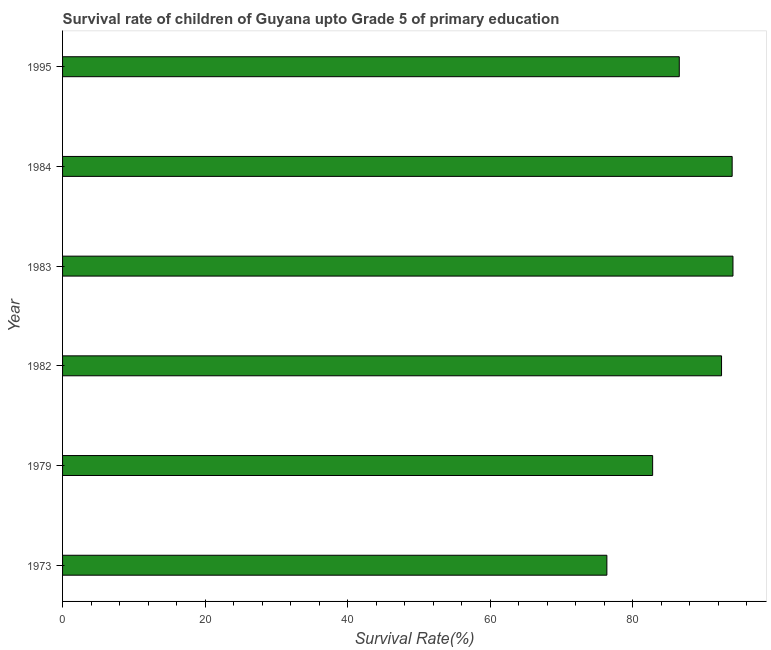Does the graph contain any zero values?
Your answer should be very brief. No. What is the title of the graph?
Offer a very short reply. Survival rate of children of Guyana upto Grade 5 of primary education. What is the label or title of the X-axis?
Ensure brevity in your answer.  Survival Rate(%). What is the label or title of the Y-axis?
Make the answer very short. Year. What is the survival rate in 1982?
Offer a terse response. 92.47. Across all years, what is the maximum survival rate?
Provide a succinct answer. 94.07. Across all years, what is the minimum survival rate?
Provide a short and direct response. 76.38. In which year was the survival rate maximum?
Keep it short and to the point. 1983. In which year was the survival rate minimum?
Your answer should be very brief. 1973. What is the sum of the survival rate?
Keep it short and to the point. 526.2. What is the difference between the survival rate in 1973 and 1979?
Ensure brevity in your answer.  -6.42. What is the average survival rate per year?
Your response must be concise. 87.7. What is the median survival rate?
Make the answer very short. 89.5. Do a majority of the years between 1984 and 1979 (inclusive) have survival rate greater than 84 %?
Keep it short and to the point. Yes. What is the ratio of the survival rate in 1982 to that in 1995?
Make the answer very short. 1.07. Is the survival rate in 1973 less than that in 1984?
Keep it short and to the point. Yes. Is the difference between the survival rate in 1973 and 1995 greater than the difference between any two years?
Provide a short and direct response. No. What is the difference between the highest and the second highest survival rate?
Your answer should be compact. 0.11. Is the sum of the survival rate in 1982 and 1984 greater than the maximum survival rate across all years?
Make the answer very short. Yes. What is the difference between the highest and the lowest survival rate?
Make the answer very short. 17.69. What is the Survival Rate(%) of 1973?
Your answer should be compact. 76.38. What is the Survival Rate(%) in 1979?
Ensure brevity in your answer.  82.8. What is the Survival Rate(%) in 1982?
Make the answer very short. 92.47. What is the Survival Rate(%) in 1983?
Your answer should be very brief. 94.07. What is the Survival Rate(%) of 1984?
Make the answer very short. 93.96. What is the Survival Rate(%) of 1995?
Your answer should be compact. 86.54. What is the difference between the Survival Rate(%) in 1973 and 1979?
Your response must be concise. -6.42. What is the difference between the Survival Rate(%) in 1973 and 1982?
Give a very brief answer. -16.09. What is the difference between the Survival Rate(%) in 1973 and 1983?
Offer a terse response. -17.69. What is the difference between the Survival Rate(%) in 1973 and 1984?
Your response must be concise. -17.58. What is the difference between the Survival Rate(%) in 1973 and 1995?
Keep it short and to the point. -10.16. What is the difference between the Survival Rate(%) in 1979 and 1982?
Offer a terse response. -9.67. What is the difference between the Survival Rate(%) in 1979 and 1983?
Keep it short and to the point. -11.27. What is the difference between the Survival Rate(%) in 1979 and 1984?
Provide a short and direct response. -11.16. What is the difference between the Survival Rate(%) in 1979 and 1995?
Your answer should be compact. -3.74. What is the difference between the Survival Rate(%) in 1982 and 1983?
Provide a succinct answer. -1.6. What is the difference between the Survival Rate(%) in 1982 and 1984?
Provide a short and direct response. -1.49. What is the difference between the Survival Rate(%) in 1982 and 1995?
Make the answer very short. 5.93. What is the difference between the Survival Rate(%) in 1983 and 1984?
Make the answer very short. 0.11. What is the difference between the Survival Rate(%) in 1983 and 1995?
Provide a short and direct response. 7.53. What is the difference between the Survival Rate(%) in 1984 and 1995?
Ensure brevity in your answer.  7.42. What is the ratio of the Survival Rate(%) in 1973 to that in 1979?
Provide a succinct answer. 0.92. What is the ratio of the Survival Rate(%) in 1973 to that in 1982?
Provide a short and direct response. 0.83. What is the ratio of the Survival Rate(%) in 1973 to that in 1983?
Your answer should be compact. 0.81. What is the ratio of the Survival Rate(%) in 1973 to that in 1984?
Your answer should be very brief. 0.81. What is the ratio of the Survival Rate(%) in 1973 to that in 1995?
Ensure brevity in your answer.  0.88. What is the ratio of the Survival Rate(%) in 1979 to that in 1982?
Your answer should be very brief. 0.9. What is the ratio of the Survival Rate(%) in 1979 to that in 1983?
Give a very brief answer. 0.88. What is the ratio of the Survival Rate(%) in 1979 to that in 1984?
Offer a very short reply. 0.88. What is the ratio of the Survival Rate(%) in 1982 to that in 1983?
Make the answer very short. 0.98. What is the ratio of the Survival Rate(%) in 1982 to that in 1984?
Provide a succinct answer. 0.98. What is the ratio of the Survival Rate(%) in 1982 to that in 1995?
Make the answer very short. 1.07. What is the ratio of the Survival Rate(%) in 1983 to that in 1984?
Offer a very short reply. 1. What is the ratio of the Survival Rate(%) in 1983 to that in 1995?
Make the answer very short. 1.09. What is the ratio of the Survival Rate(%) in 1984 to that in 1995?
Provide a short and direct response. 1.09. 